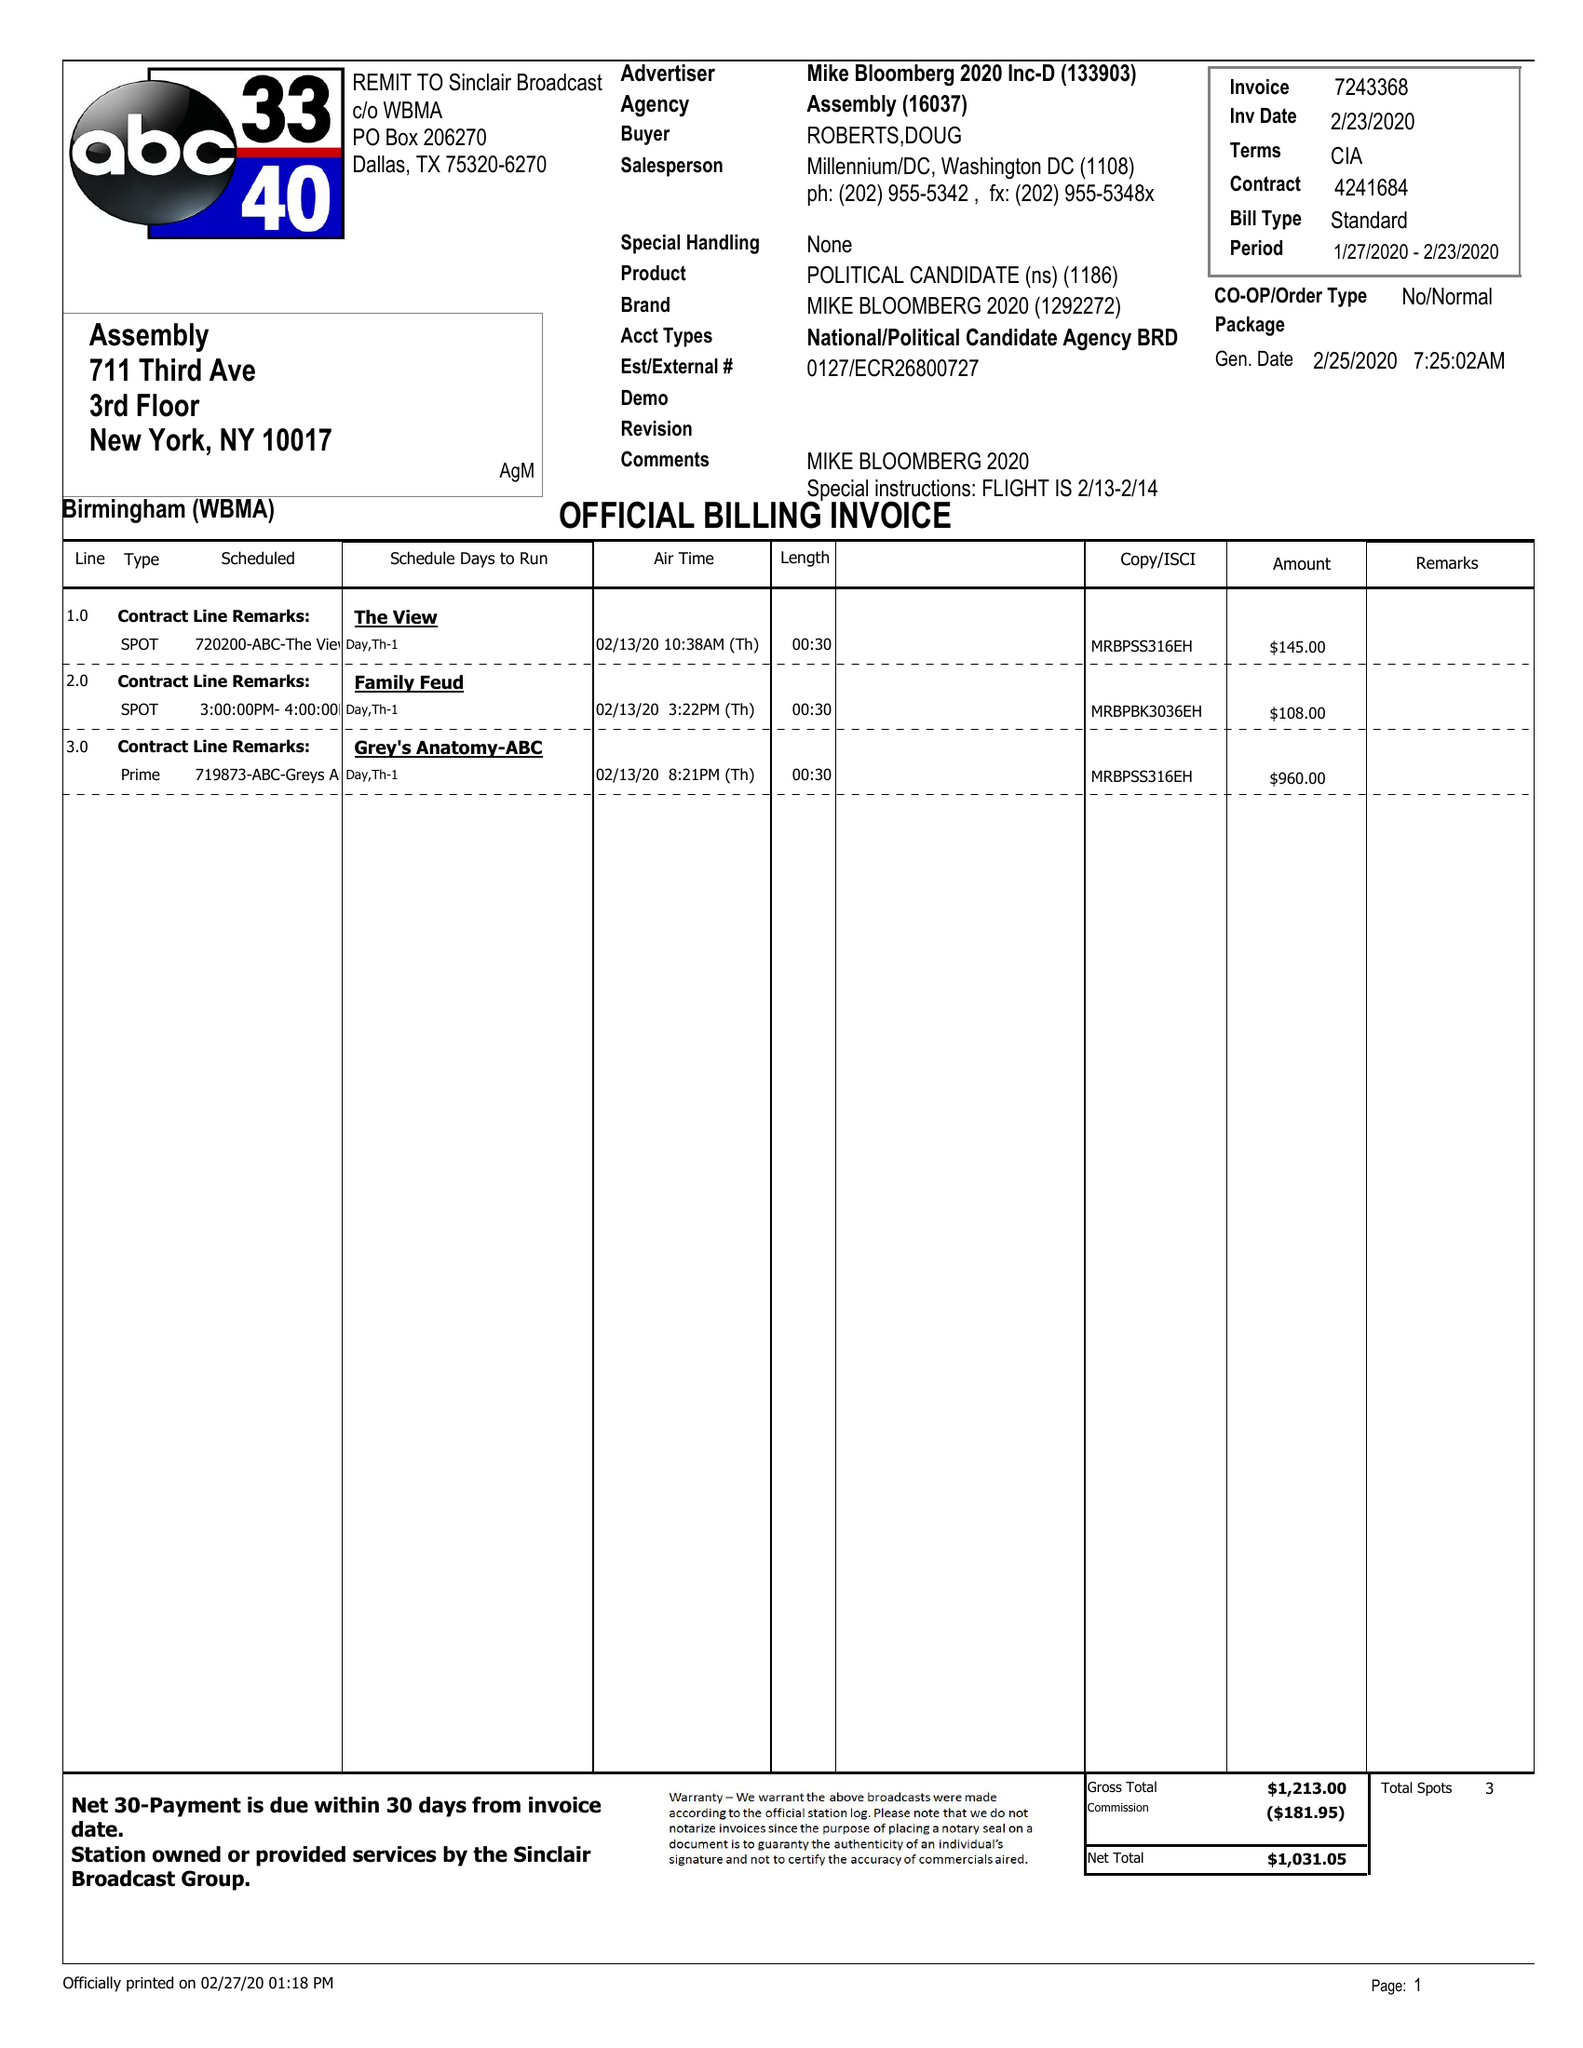What is the value for the advertiser?
Answer the question using a single word or phrase. MIKE BLOOMBERG 2020 INC-D 